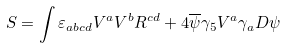<formula> <loc_0><loc_0><loc_500><loc_500>S = \int \varepsilon _ { a b c d } V ^ { a } V ^ { b } R ^ { c d } + 4 \overline { \psi } \gamma _ { 5 } V ^ { a } \gamma _ { a } D \psi</formula> 